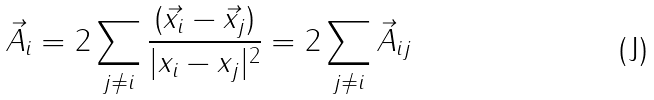Convert formula to latex. <formula><loc_0><loc_0><loc_500><loc_500>\vec { A } _ { i } = 2 \sum _ { j \neq i } \frac { ( \vec { x } _ { i } - \vec { x } _ { j } ) } { | x _ { i } - x _ { j } | ^ { 2 } } = 2 \sum _ { j \neq i } \vec { A } _ { i j }</formula> 